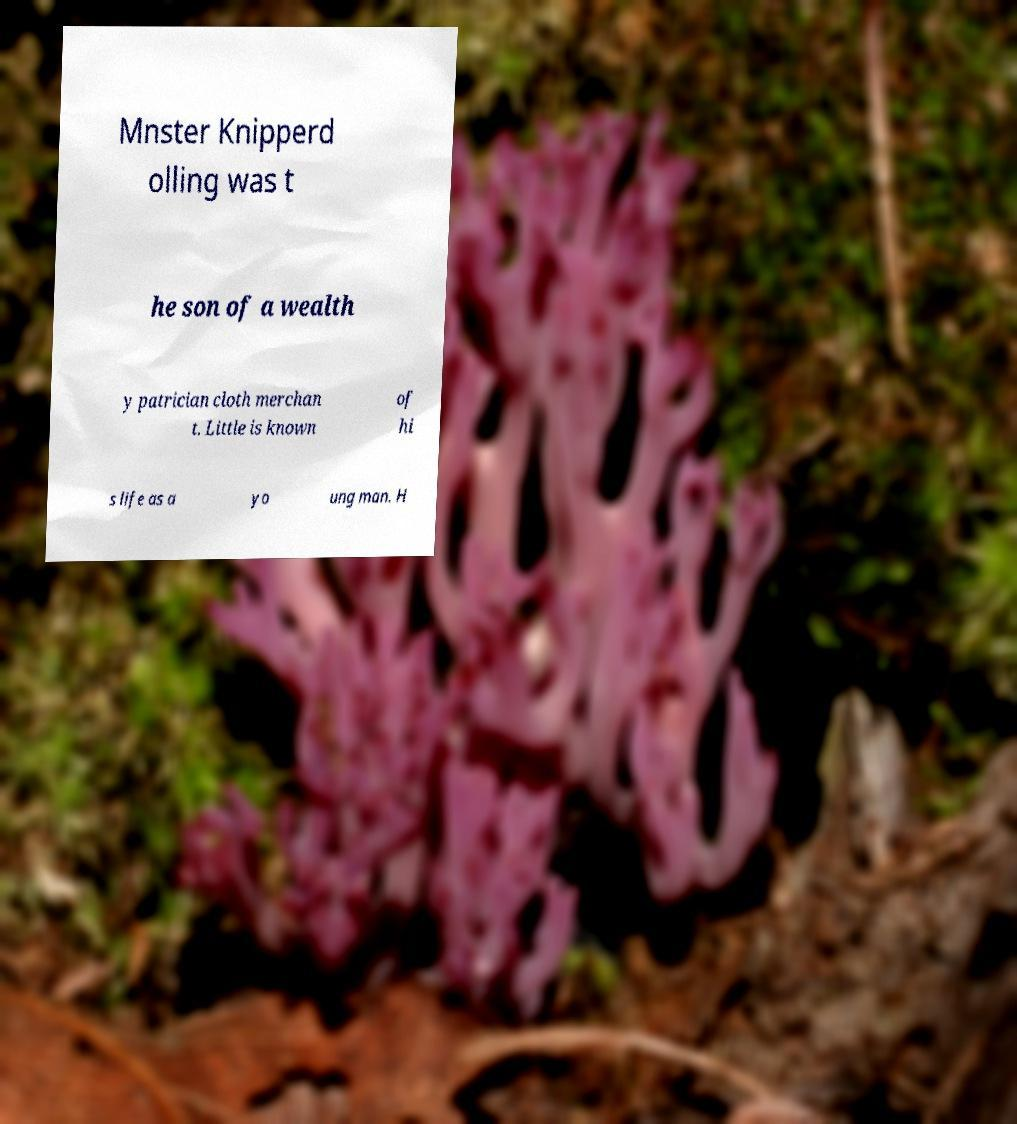What messages or text are displayed in this image? I need them in a readable, typed format. Mnster Knipperd olling was t he son of a wealth y patrician cloth merchan t. Little is known of hi s life as a yo ung man. H 